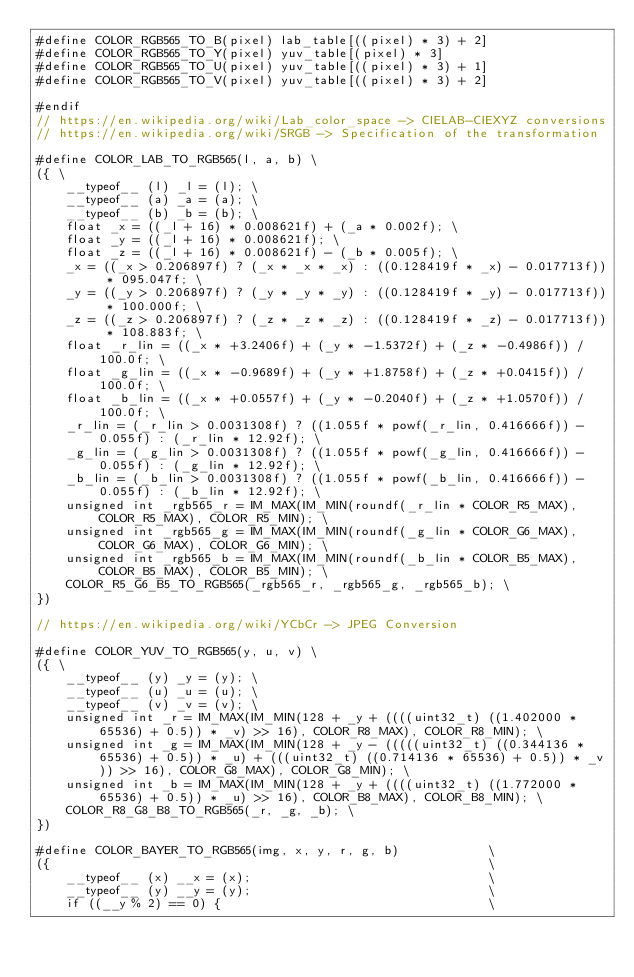Convert code to text. <code><loc_0><loc_0><loc_500><loc_500><_C_>#define COLOR_RGB565_TO_B(pixel) lab_table[((pixel) * 3) + 2]
#define COLOR_RGB565_TO_Y(pixel) yuv_table[(pixel) * 3]
#define COLOR_RGB565_TO_U(pixel) yuv_table[((pixel) * 3) + 1]
#define COLOR_RGB565_TO_V(pixel) yuv_table[((pixel) * 3) + 2]

#endif
// https://en.wikipedia.org/wiki/Lab_color_space -> CIELAB-CIEXYZ conversions
// https://en.wikipedia.org/wiki/SRGB -> Specification of the transformation

#define COLOR_LAB_TO_RGB565(l, a, b) \
({ \
    __typeof__ (l) _l = (l); \
    __typeof__ (a) _a = (a); \
    __typeof__ (b) _b = (b); \
    float _x = ((_l + 16) * 0.008621f) + (_a * 0.002f); \
    float _y = ((_l + 16) * 0.008621f); \
    float _z = ((_l + 16) * 0.008621f) - (_b * 0.005f); \
    _x = ((_x > 0.206897f) ? (_x * _x * _x) : ((0.128419f * _x) - 0.017713f)) * 095.047f; \
    _y = ((_y > 0.206897f) ? (_y * _y * _y) : ((0.128419f * _y) - 0.017713f)) * 100.000f; \
    _z = ((_z > 0.206897f) ? (_z * _z * _z) : ((0.128419f * _z) - 0.017713f)) * 108.883f; \
    float _r_lin = ((_x * +3.2406f) + (_y * -1.5372f) + (_z * -0.4986f)) / 100.0f; \
    float _g_lin = ((_x * -0.9689f) + (_y * +1.8758f) + (_z * +0.0415f)) / 100.0f; \
    float _b_lin = ((_x * +0.0557f) + (_y * -0.2040f) + (_z * +1.0570f)) / 100.0f; \
    _r_lin = (_r_lin > 0.0031308f) ? ((1.055f * powf(_r_lin, 0.416666f)) - 0.055f) : (_r_lin * 12.92f); \
    _g_lin = (_g_lin > 0.0031308f) ? ((1.055f * powf(_g_lin, 0.416666f)) - 0.055f) : (_g_lin * 12.92f); \
    _b_lin = (_b_lin > 0.0031308f) ? ((1.055f * powf(_b_lin, 0.416666f)) - 0.055f) : (_b_lin * 12.92f); \
    unsigned int _rgb565_r = IM_MAX(IM_MIN(roundf(_r_lin * COLOR_R5_MAX), COLOR_R5_MAX), COLOR_R5_MIN); \
    unsigned int _rgb565_g = IM_MAX(IM_MIN(roundf(_g_lin * COLOR_G6_MAX), COLOR_G6_MAX), COLOR_G6_MIN); \
    unsigned int _rgb565_b = IM_MAX(IM_MIN(roundf(_b_lin * COLOR_B5_MAX), COLOR_B5_MAX), COLOR_B5_MIN); \
    COLOR_R5_G6_B5_TO_RGB565(_rgb565_r, _rgb565_g, _rgb565_b); \
})

// https://en.wikipedia.org/wiki/YCbCr -> JPEG Conversion

#define COLOR_YUV_TO_RGB565(y, u, v) \
({ \
    __typeof__ (y) _y = (y); \
    __typeof__ (u) _u = (u); \
    __typeof__ (v) _v = (v); \
    unsigned int _r = IM_MAX(IM_MIN(128 + _y + ((((uint32_t) ((1.402000 * 65536) + 0.5)) * _v) >> 16), COLOR_R8_MAX), COLOR_R8_MIN); \
    unsigned int _g = IM_MAX(IM_MIN(128 + _y - (((((uint32_t) ((0.344136 * 65536) + 0.5)) * _u) + (((uint32_t) ((0.714136 * 65536) + 0.5)) * _v)) >> 16), COLOR_G8_MAX), COLOR_G8_MIN); \
    unsigned int _b = IM_MAX(IM_MIN(128 + _y + ((((uint32_t) ((1.772000 * 65536) + 0.5)) * _u) >> 16), COLOR_B8_MAX), COLOR_B8_MIN); \
    COLOR_R8_G8_B8_TO_RGB565(_r, _g, _b); \
})

#define COLOR_BAYER_TO_RGB565(img, x, y, r, g, b)            \
({                                                           \
    __typeof__ (x) __x = (x);                                \
    __typeof__ (y) __y = (y);                                \
    if ((__y % 2) == 0) {                                    \</code> 